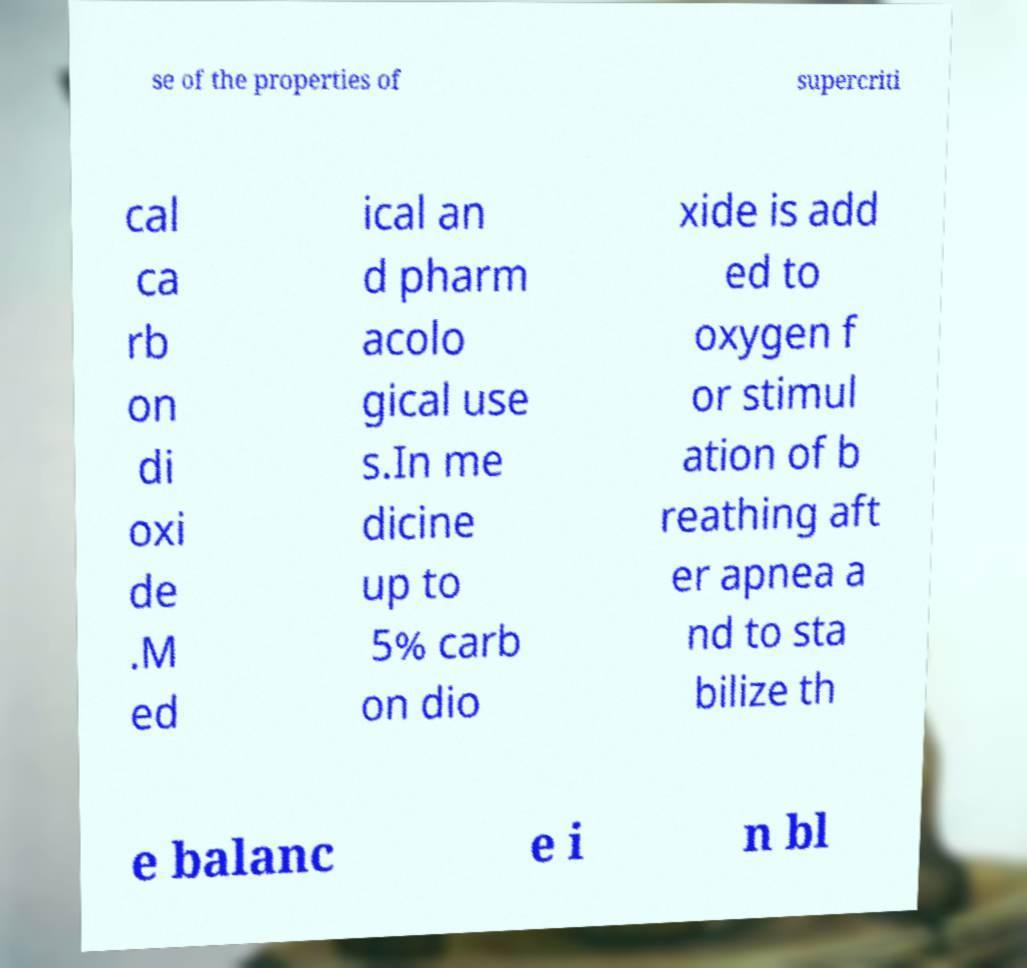Can you read and provide the text displayed in the image?This photo seems to have some interesting text. Can you extract and type it out for me? se of the properties of supercriti cal ca rb on di oxi de .M ed ical an d pharm acolo gical use s.In me dicine up to 5% carb on dio xide is add ed to oxygen f or stimul ation of b reathing aft er apnea a nd to sta bilize th e balanc e i n bl 